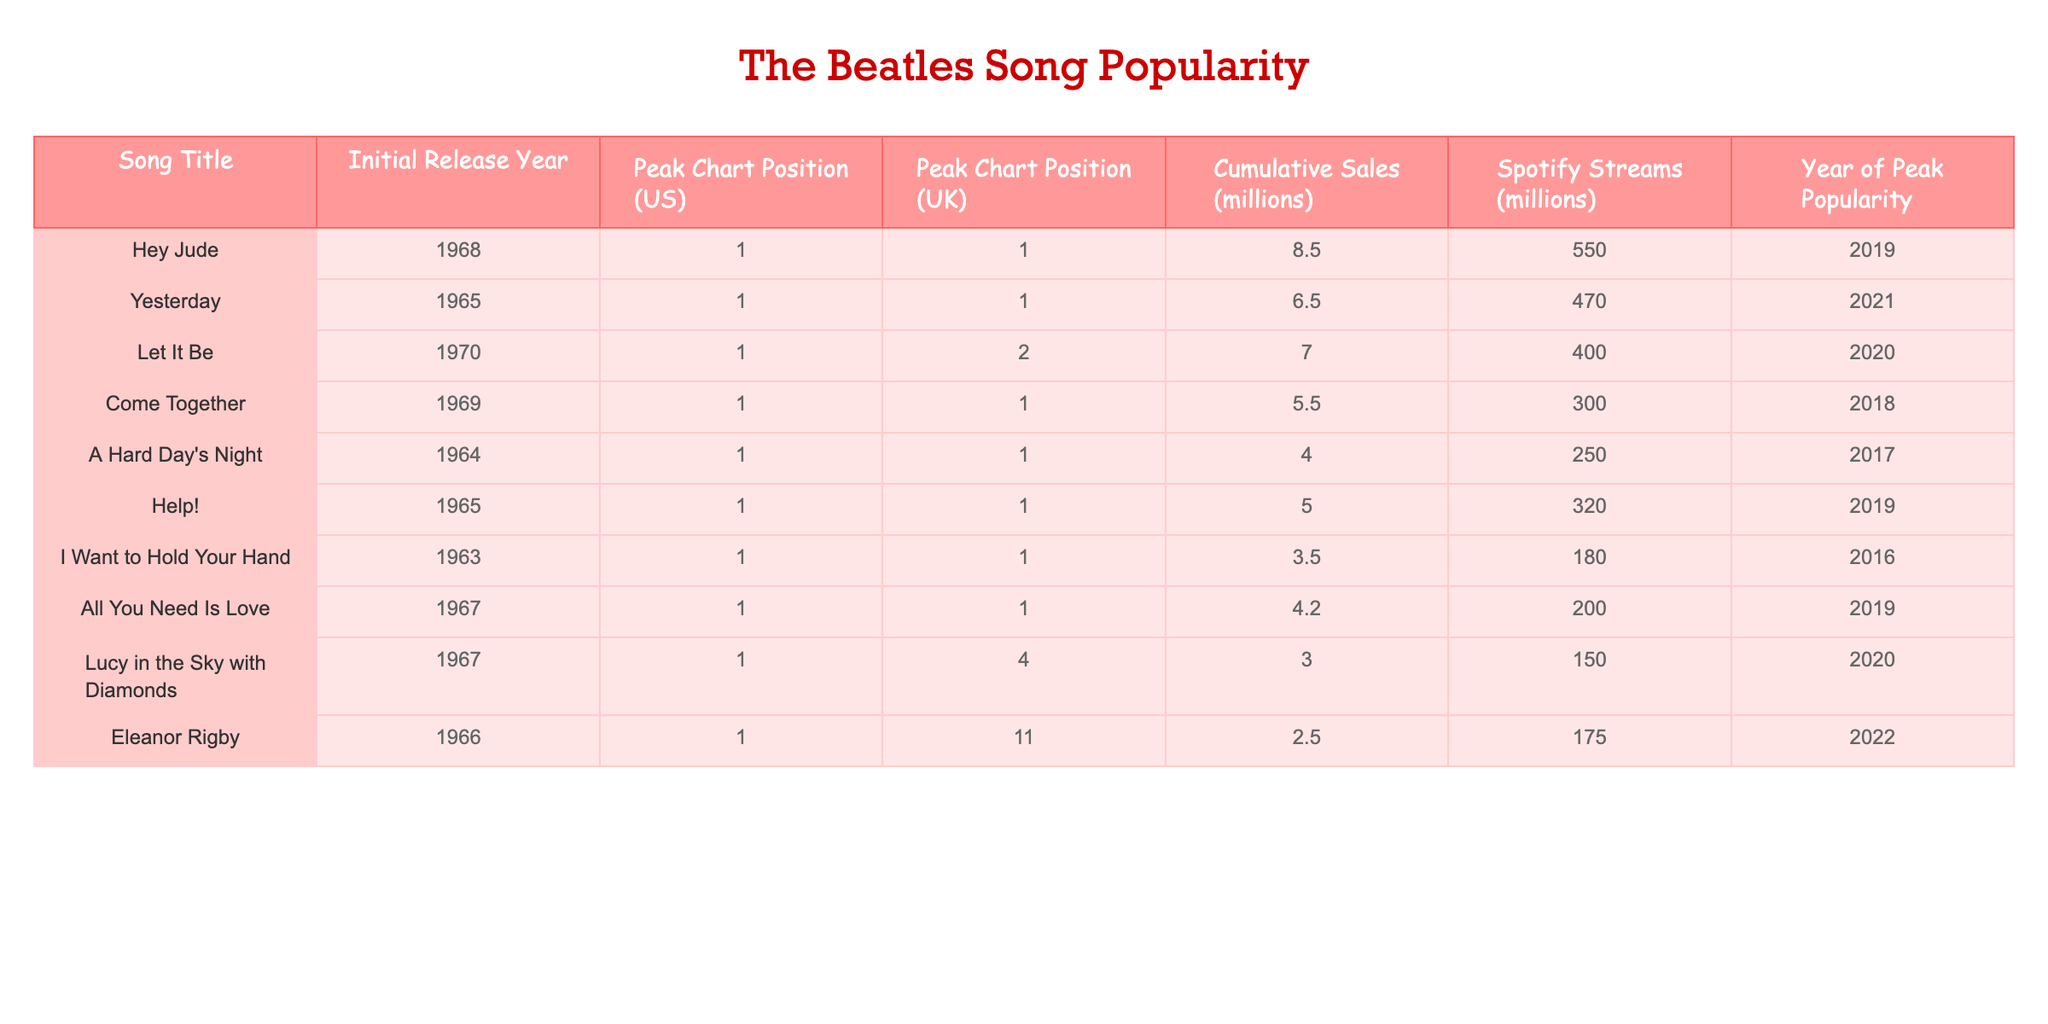What is the cumulative sales of "Yesterday"? The table shows that "Yesterday" has cumulative sales of 6.5 million.
Answer: 6.5 million Which song has the highest Spotify streams? By examining the Spotify streams column, "Hey Jude" has 550 million streams, which is the highest among all songs.
Answer: Hey Jude What was the peak chart position of "Let It Be" in the UK? Looking at the UK peak chart position for "Let It Be," the table indicates it peaked at position 2.
Answer: 2 Do any songs released before 1965 have a higher cumulative sales than "Eleanor Rigby"? "Help!" (5.0 million), "A Hard Day's Night" (4.0 million), and "I Want to Hold Your Hand" (3.5 million) all have higher cumulative sales than "Eleanor Rigby" (2.5 million). Thus, the answer is yes.
Answer: Yes What is the average peak chart position for songs recorded in the 1960s? The peak positions for songs from the 1960s are: "Hey Jude" (1), "Come Together" (1), "Lucy in the Sky with Diamonds" (4), "Eleanor Rigby" (11), and "All You Need Is Love" (1). To find the average, we sum them up (1 + 1 + 4 + 11 + 1 = 18) and divide by the number of songs (5), which gives us 18/5 = 3.6.
Answer: 3.6 Which song was the last to achieve peak popularity? By checking the Year of Peak Popularity column, "Eleanor Rigby" achieved its peak popularity in 2022, making it the last to do so.
Answer: Eleanor Rigby What percentage of Spotify streams does "Let It Be" have compared to "Hey Jude"? To find the percentage, calculate (Spotify streams of Let It Be / Spotify streams of Hey Jude) * 100. That's (400 / 550) * 100, which equals approximately 72.73%.
Answer: 72.73% How many songs in the table peaked at the number 1 position in the US? From the table, the songs that peaked at number 1 in the US are: "Hey Jude," "Come Together," "A Hard Day's Night," "Help!" and "I Want to Hold Your Hand." This totals to 5 songs.
Answer: 5 Is "Yesterday" the only song released in 1965 that peaked at number 1? The table lists both "Yesterday" and "Help!" as songs released in 1965 that peaked at number 1, so "Yesterday" is not the only one.
Answer: No 